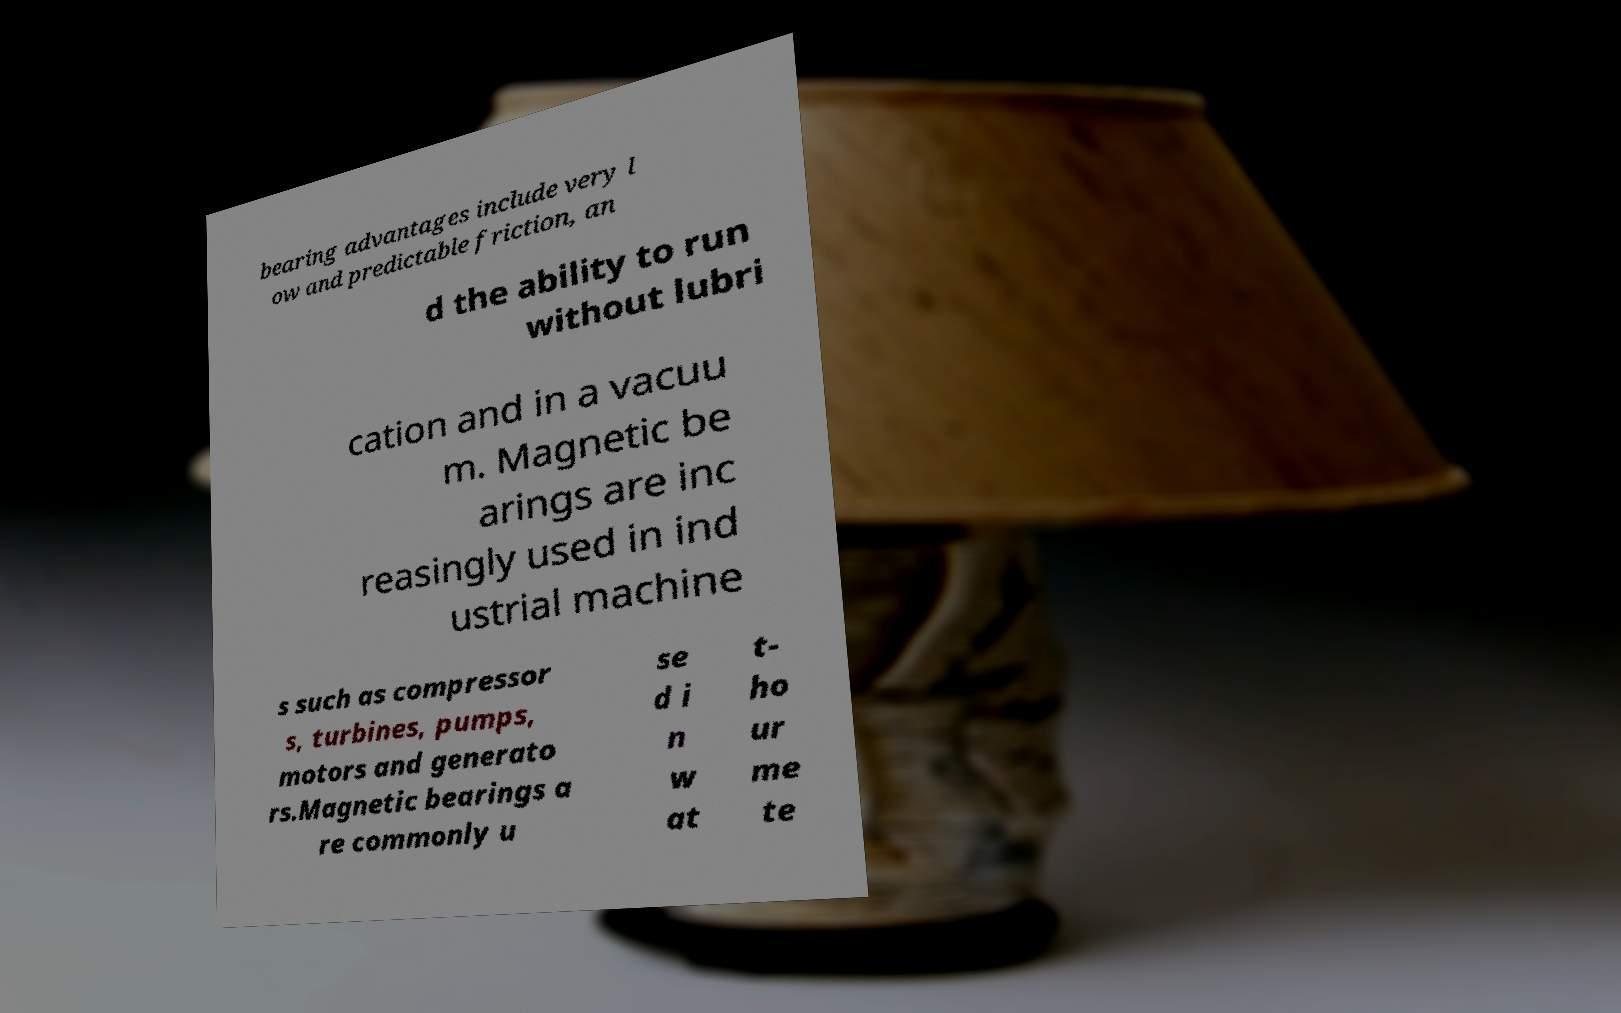Please read and relay the text visible in this image. What does it say? bearing advantages include very l ow and predictable friction, an d the ability to run without lubri cation and in a vacuu m. Magnetic be arings are inc reasingly used in ind ustrial machine s such as compressor s, turbines, pumps, motors and generato rs.Magnetic bearings a re commonly u se d i n w at t- ho ur me te 